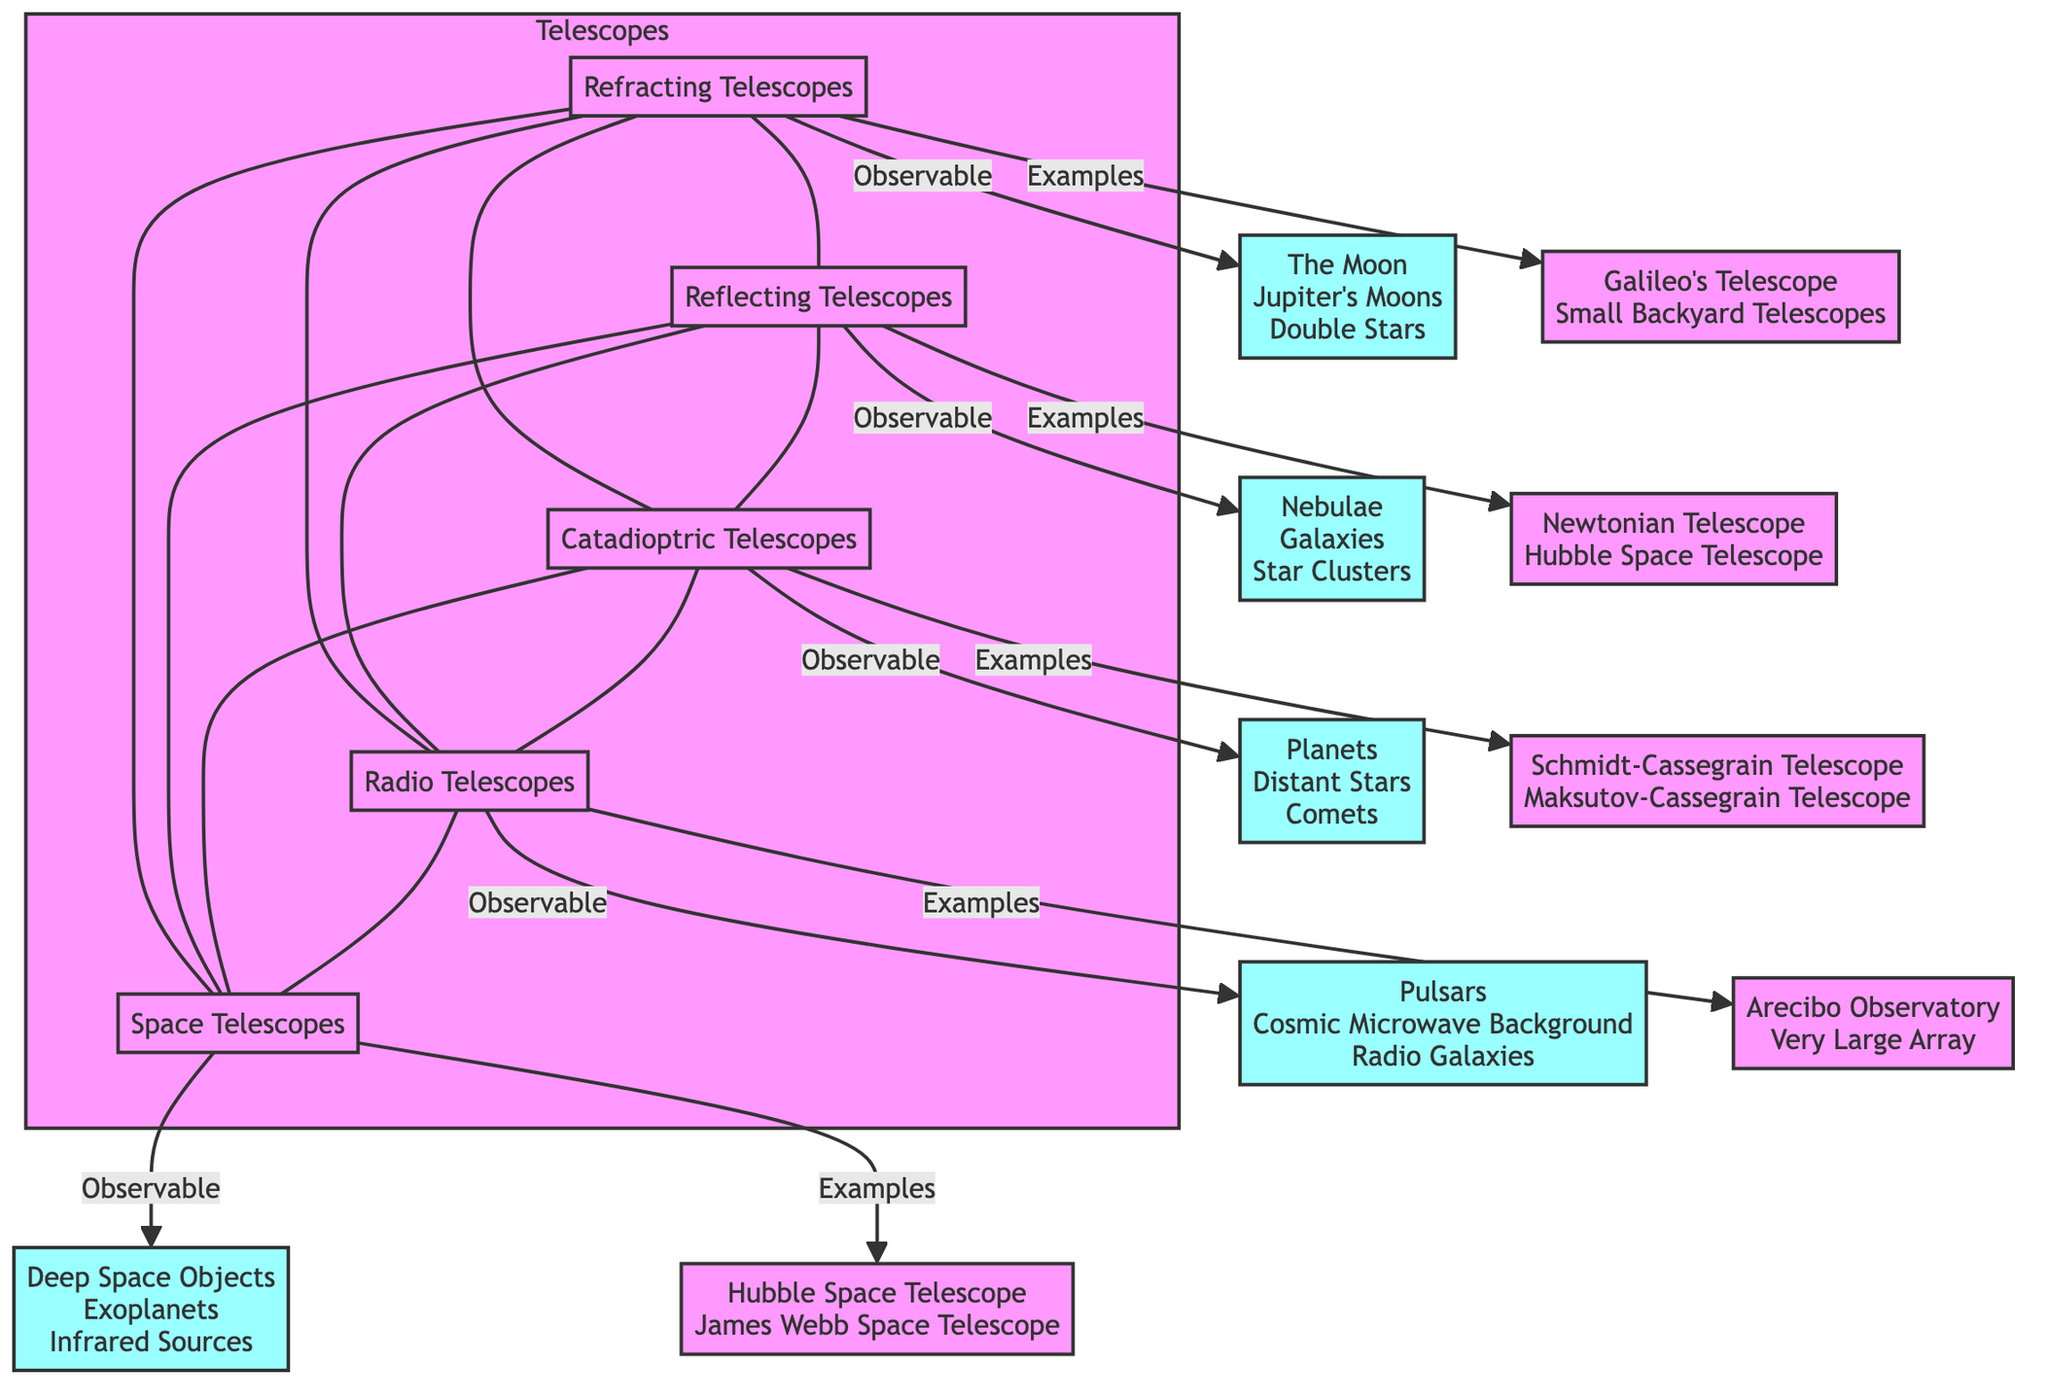How many types of telescopes are shown in the diagram? The diagram lists five types of telescopes: Refracting, Reflecting, Catadioptric, Radio, and Space Telescopes. These can be counted as distinct nodes in the "Telescopes" subgraph.
Answer: 5 What objects are observable through a Reflecting Telescope? The diagram indicates that nebulae, galaxies, and star clusters are observable through Reflecting Telescopes. This information can be found under the observable section connected to the Reflecting Telescope node.
Answer: Nebulae, Galaxies, Star Clusters Which telescope type can observe cosmic microwave background? The diagram specifies that the Radio Telescope type has the cosmic microwave background listed under its observable objects. Thus, this observation is linked directly to the Radio Telescope node.
Answer: Radio Telescopes What are the examples provided for Catadioptric Telescopes? The Catadioptric Telescopes node connects to examples such as Schmidt-Cassegrain Telescope and Maksutov-Cassegrain Telescope. This information can be easily identified beneath the examples label for that telescope type.
Answer: Schmidt-Cassegrain Telescope, Maksutov-Cassegrain Telescope Which telescope type is connected to both Radio Telescopes and Space Telescopes? The diagram illustrates that Reflecting Telescopes connect to both Radio Telescopes and Space Telescopes through direct edges. This means Reflecting Telescopes are the type that connects to both of these.
Answer: Reflecting Telescopes What types of objects can be observed with Space Telescopes? The observable section for Space Telescopes indicates deep space objects, exoplanets, and infrared sources, all of which are listed and connected specifically to the Space Telescopes node.
Answer: Deep Space Objects, Exoplanets, Infrared Sources How many observable objects are listed for Refracting Telescopes? The diagram indicates three observable objects for Refracting Telescopes: The Moon, Jupiter's Moons, and Double Stars. They can be counted directly from the Refracting Telescope’s observable node.
Answer: 3 Which example is provided for Radio Telescopes? The Arecibo Observatory is listed under the examples for Radio Telescopes in the diagram, indicating a specific instance of this type of telescope.
Answer: Arecibo Observatory What telescope type is Hubble Space Telescope an example of? The diagram shows that the Hubble Space Telescope appears as an example under both Reflecting and Space Telescopes. This dual connection shows its relevance to both types.
Answer: Reflecting Telescopes, Space Telescopes 